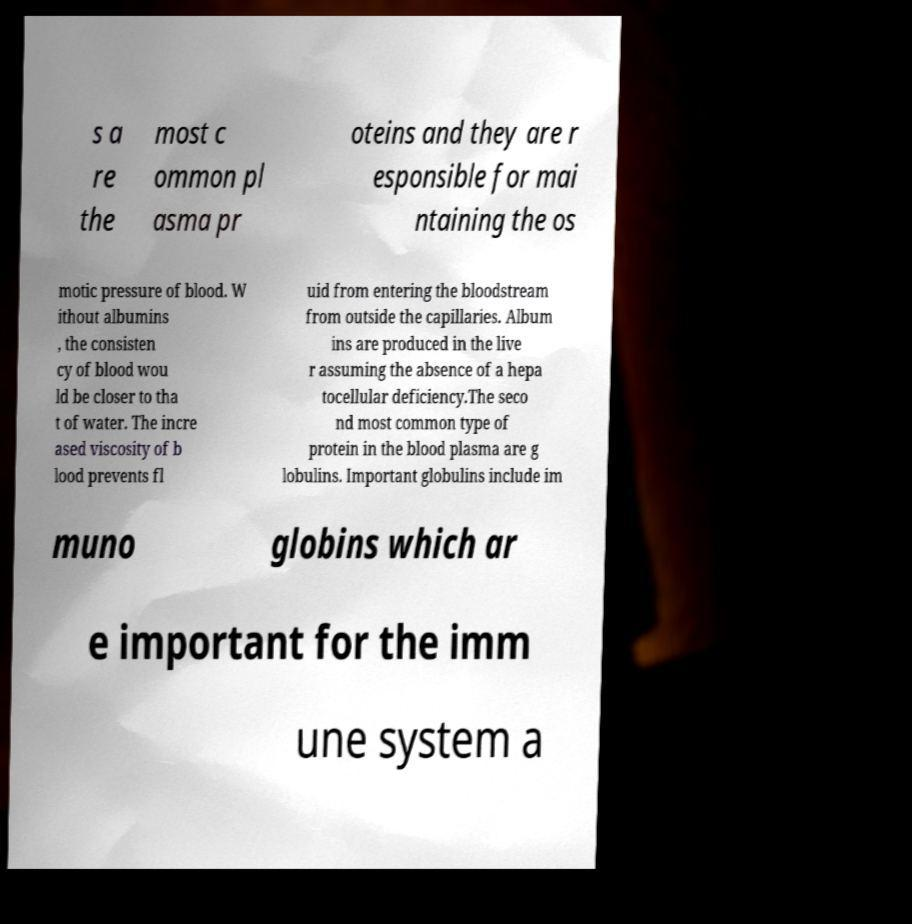I need the written content from this picture converted into text. Can you do that? s a re the most c ommon pl asma pr oteins and they are r esponsible for mai ntaining the os motic pressure of blood. W ithout albumins , the consisten cy of blood wou ld be closer to tha t of water. The incre ased viscosity of b lood prevents fl uid from entering the bloodstream from outside the capillaries. Album ins are produced in the live r assuming the absence of a hepa tocellular deficiency.The seco nd most common type of protein in the blood plasma are g lobulins. Important globulins include im muno globins which ar e important for the imm une system a 